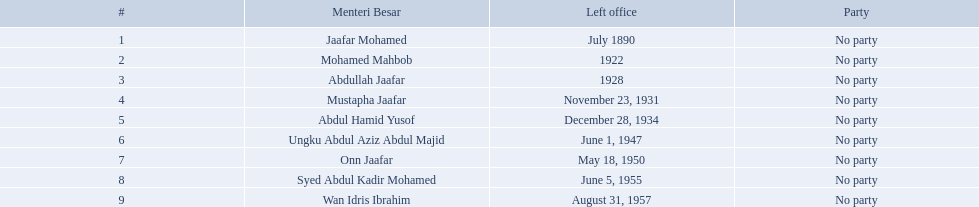Who were the menteri besar of johor? Jaafar Mohamed, Mohamed Mahbob, Abdullah Jaafar, Mustapha Jaafar, Abdul Hamid Yusof, Ungku Abdul Aziz Abdul Majid, Onn Jaafar, Syed Abdul Kadir Mohamed, Wan Idris Ibrahim. Who served the longest? Ungku Abdul Aziz Abdul Majid. When did jaafar mohamed take office? 1886. When did mohamed mahbob take office? June 1920. Who was in office no more than 4 years? Mohamed Mahbob. 